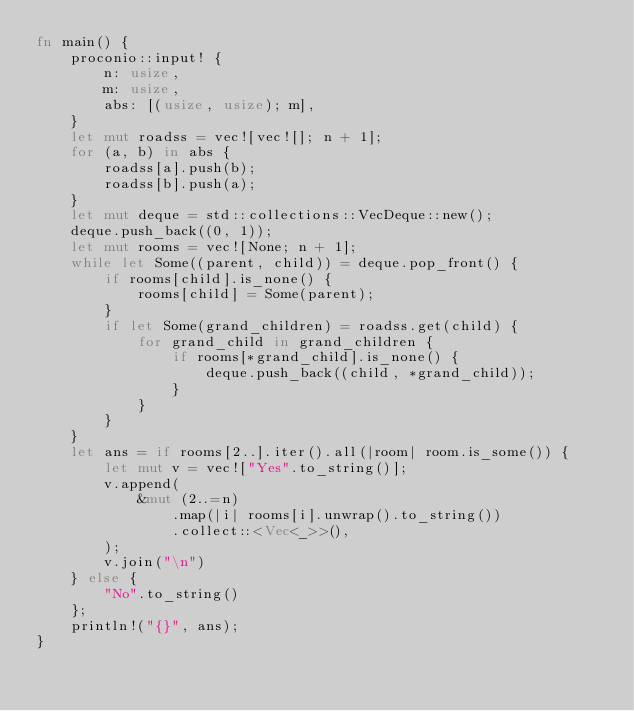Convert code to text. <code><loc_0><loc_0><loc_500><loc_500><_Rust_>fn main() {
    proconio::input! {
        n: usize,
        m: usize,
        abs: [(usize, usize); m],
    }
    let mut roadss = vec![vec![]; n + 1];
    for (a, b) in abs {
        roadss[a].push(b);
        roadss[b].push(a);
    }
    let mut deque = std::collections::VecDeque::new();
    deque.push_back((0, 1));
    let mut rooms = vec![None; n + 1];
    while let Some((parent, child)) = deque.pop_front() {
        if rooms[child].is_none() {
            rooms[child] = Some(parent);
        }
        if let Some(grand_children) = roadss.get(child) {
            for grand_child in grand_children {
                if rooms[*grand_child].is_none() {
                    deque.push_back((child, *grand_child));
                }
            }
        }
    }
    let ans = if rooms[2..].iter().all(|room| room.is_some()) {
        let mut v = vec!["Yes".to_string()];
        v.append(
            &mut (2..=n)
                .map(|i| rooms[i].unwrap().to_string())
                .collect::<Vec<_>>(),
        );
        v.join("\n")
    } else {
        "No".to_string()
    };
    println!("{}", ans);
}
</code> 